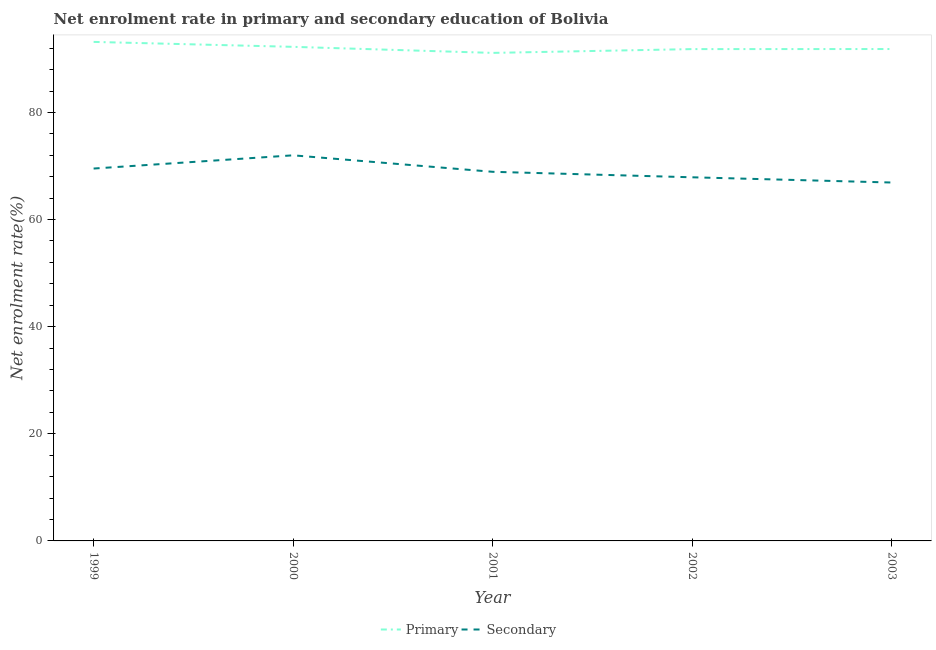How many different coloured lines are there?
Give a very brief answer. 2. Does the line corresponding to enrollment rate in primary education intersect with the line corresponding to enrollment rate in secondary education?
Keep it short and to the point. No. What is the enrollment rate in primary education in 2003?
Offer a very short reply. 91.84. Across all years, what is the maximum enrollment rate in primary education?
Ensure brevity in your answer.  93.17. Across all years, what is the minimum enrollment rate in secondary education?
Give a very brief answer. 66.92. In which year was the enrollment rate in primary education maximum?
Offer a terse response. 1999. In which year was the enrollment rate in primary education minimum?
Offer a terse response. 2001. What is the total enrollment rate in secondary education in the graph?
Give a very brief answer. 345.25. What is the difference between the enrollment rate in secondary education in 1999 and that in 2002?
Your answer should be very brief. 1.63. What is the difference between the enrollment rate in primary education in 2002 and the enrollment rate in secondary education in 2001?
Give a very brief answer. 22.91. What is the average enrollment rate in primary education per year?
Offer a terse response. 92.04. In the year 2003, what is the difference between the enrollment rate in primary education and enrollment rate in secondary education?
Make the answer very short. 24.92. What is the ratio of the enrollment rate in primary education in 2001 to that in 2002?
Make the answer very short. 0.99. Is the difference between the enrollment rate in secondary education in 1999 and 2001 greater than the difference between the enrollment rate in primary education in 1999 and 2001?
Your answer should be compact. No. What is the difference between the highest and the second highest enrollment rate in secondary education?
Ensure brevity in your answer.  2.47. What is the difference between the highest and the lowest enrollment rate in secondary education?
Make the answer very short. 5.08. In how many years, is the enrollment rate in secondary education greater than the average enrollment rate in secondary education taken over all years?
Your response must be concise. 2. Does the enrollment rate in primary education monotonically increase over the years?
Offer a very short reply. No. How many lines are there?
Your response must be concise. 2. How many years are there in the graph?
Make the answer very short. 5. What is the difference between two consecutive major ticks on the Y-axis?
Your answer should be very brief. 20. Are the values on the major ticks of Y-axis written in scientific E-notation?
Provide a succinct answer. No. Does the graph contain grids?
Provide a short and direct response. No. Where does the legend appear in the graph?
Make the answer very short. Bottom center. How many legend labels are there?
Give a very brief answer. 2. How are the legend labels stacked?
Make the answer very short. Horizontal. What is the title of the graph?
Ensure brevity in your answer.  Net enrolment rate in primary and secondary education of Bolivia. What is the label or title of the X-axis?
Keep it short and to the point. Year. What is the label or title of the Y-axis?
Keep it short and to the point. Net enrolment rate(%). What is the Net enrolment rate(%) in Primary in 1999?
Give a very brief answer. 93.17. What is the Net enrolment rate(%) of Secondary in 1999?
Your answer should be compact. 69.53. What is the Net enrolment rate(%) of Primary in 2000?
Your answer should be very brief. 92.25. What is the Net enrolment rate(%) of Secondary in 2000?
Your answer should be compact. 72. What is the Net enrolment rate(%) in Primary in 2001?
Provide a short and direct response. 91.12. What is the Net enrolment rate(%) in Secondary in 2001?
Your response must be concise. 68.92. What is the Net enrolment rate(%) of Primary in 2002?
Offer a terse response. 91.83. What is the Net enrolment rate(%) of Secondary in 2002?
Provide a succinct answer. 67.89. What is the Net enrolment rate(%) in Primary in 2003?
Offer a terse response. 91.84. What is the Net enrolment rate(%) of Secondary in 2003?
Ensure brevity in your answer.  66.92. Across all years, what is the maximum Net enrolment rate(%) in Primary?
Make the answer very short. 93.17. Across all years, what is the maximum Net enrolment rate(%) of Secondary?
Offer a terse response. 72. Across all years, what is the minimum Net enrolment rate(%) in Primary?
Offer a terse response. 91.12. Across all years, what is the minimum Net enrolment rate(%) of Secondary?
Offer a very short reply. 66.92. What is the total Net enrolment rate(%) in Primary in the graph?
Provide a succinct answer. 460.21. What is the total Net enrolment rate(%) in Secondary in the graph?
Ensure brevity in your answer.  345.25. What is the difference between the Net enrolment rate(%) in Primary in 1999 and that in 2000?
Your answer should be very brief. 0.92. What is the difference between the Net enrolment rate(%) in Secondary in 1999 and that in 2000?
Give a very brief answer. -2.47. What is the difference between the Net enrolment rate(%) of Primary in 1999 and that in 2001?
Keep it short and to the point. 2.05. What is the difference between the Net enrolment rate(%) of Secondary in 1999 and that in 2001?
Make the answer very short. 0.61. What is the difference between the Net enrolment rate(%) in Primary in 1999 and that in 2002?
Ensure brevity in your answer.  1.34. What is the difference between the Net enrolment rate(%) in Secondary in 1999 and that in 2002?
Give a very brief answer. 1.63. What is the difference between the Net enrolment rate(%) in Primary in 1999 and that in 2003?
Provide a short and direct response. 1.33. What is the difference between the Net enrolment rate(%) of Secondary in 1999 and that in 2003?
Your response must be concise. 2.61. What is the difference between the Net enrolment rate(%) of Primary in 2000 and that in 2001?
Your answer should be compact. 1.13. What is the difference between the Net enrolment rate(%) of Secondary in 2000 and that in 2001?
Give a very brief answer. 3.08. What is the difference between the Net enrolment rate(%) in Primary in 2000 and that in 2002?
Your answer should be compact. 0.42. What is the difference between the Net enrolment rate(%) of Secondary in 2000 and that in 2002?
Offer a very short reply. 4.1. What is the difference between the Net enrolment rate(%) in Primary in 2000 and that in 2003?
Your answer should be compact. 0.41. What is the difference between the Net enrolment rate(%) of Secondary in 2000 and that in 2003?
Provide a short and direct response. 5.08. What is the difference between the Net enrolment rate(%) of Primary in 2001 and that in 2002?
Give a very brief answer. -0.71. What is the difference between the Net enrolment rate(%) in Secondary in 2001 and that in 2002?
Keep it short and to the point. 1.03. What is the difference between the Net enrolment rate(%) of Primary in 2001 and that in 2003?
Your answer should be very brief. -0.72. What is the difference between the Net enrolment rate(%) of Secondary in 2001 and that in 2003?
Your response must be concise. 2. What is the difference between the Net enrolment rate(%) in Primary in 2002 and that in 2003?
Offer a very short reply. -0.01. What is the difference between the Net enrolment rate(%) in Secondary in 2002 and that in 2003?
Your response must be concise. 0.98. What is the difference between the Net enrolment rate(%) in Primary in 1999 and the Net enrolment rate(%) in Secondary in 2000?
Ensure brevity in your answer.  21.18. What is the difference between the Net enrolment rate(%) of Primary in 1999 and the Net enrolment rate(%) of Secondary in 2001?
Your response must be concise. 24.25. What is the difference between the Net enrolment rate(%) in Primary in 1999 and the Net enrolment rate(%) in Secondary in 2002?
Make the answer very short. 25.28. What is the difference between the Net enrolment rate(%) in Primary in 1999 and the Net enrolment rate(%) in Secondary in 2003?
Give a very brief answer. 26.25. What is the difference between the Net enrolment rate(%) in Primary in 2000 and the Net enrolment rate(%) in Secondary in 2001?
Make the answer very short. 23.33. What is the difference between the Net enrolment rate(%) in Primary in 2000 and the Net enrolment rate(%) in Secondary in 2002?
Keep it short and to the point. 24.36. What is the difference between the Net enrolment rate(%) of Primary in 2000 and the Net enrolment rate(%) of Secondary in 2003?
Keep it short and to the point. 25.33. What is the difference between the Net enrolment rate(%) in Primary in 2001 and the Net enrolment rate(%) in Secondary in 2002?
Make the answer very short. 23.23. What is the difference between the Net enrolment rate(%) in Primary in 2001 and the Net enrolment rate(%) in Secondary in 2003?
Your answer should be compact. 24.2. What is the difference between the Net enrolment rate(%) in Primary in 2002 and the Net enrolment rate(%) in Secondary in 2003?
Offer a terse response. 24.91. What is the average Net enrolment rate(%) of Primary per year?
Provide a succinct answer. 92.04. What is the average Net enrolment rate(%) in Secondary per year?
Ensure brevity in your answer.  69.05. In the year 1999, what is the difference between the Net enrolment rate(%) of Primary and Net enrolment rate(%) of Secondary?
Provide a succinct answer. 23.64. In the year 2000, what is the difference between the Net enrolment rate(%) of Primary and Net enrolment rate(%) of Secondary?
Offer a very short reply. 20.25. In the year 2001, what is the difference between the Net enrolment rate(%) of Primary and Net enrolment rate(%) of Secondary?
Ensure brevity in your answer.  22.2. In the year 2002, what is the difference between the Net enrolment rate(%) in Primary and Net enrolment rate(%) in Secondary?
Your answer should be compact. 23.93. In the year 2003, what is the difference between the Net enrolment rate(%) in Primary and Net enrolment rate(%) in Secondary?
Your answer should be very brief. 24.92. What is the ratio of the Net enrolment rate(%) of Primary in 1999 to that in 2000?
Make the answer very short. 1.01. What is the ratio of the Net enrolment rate(%) in Secondary in 1999 to that in 2000?
Ensure brevity in your answer.  0.97. What is the ratio of the Net enrolment rate(%) in Primary in 1999 to that in 2001?
Provide a succinct answer. 1.02. What is the ratio of the Net enrolment rate(%) of Secondary in 1999 to that in 2001?
Your response must be concise. 1.01. What is the ratio of the Net enrolment rate(%) of Primary in 1999 to that in 2002?
Give a very brief answer. 1.01. What is the ratio of the Net enrolment rate(%) of Secondary in 1999 to that in 2002?
Your response must be concise. 1.02. What is the ratio of the Net enrolment rate(%) of Primary in 1999 to that in 2003?
Your response must be concise. 1.01. What is the ratio of the Net enrolment rate(%) in Secondary in 1999 to that in 2003?
Offer a terse response. 1.04. What is the ratio of the Net enrolment rate(%) in Primary in 2000 to that in 2001?
Give a very brief answer. 1.01. What is the ratio of the Net enrolment rate(%) in Secondary in 2000 to that in 2001?
Offer a very short reply. 1.04. What is the ratio of the Net enrolment rate(%) in Secondary in 2000 to that in 2002?
Make the answer very short. 1.06. What is the ratio of the Net enrolment rate(%) in Primary in 2000 to that in 2003?
Provide a succinct answer. 1. What is the ratio of the Net enrolment rate(%) of Secondary in 2000 to that in 2003?
Provide a short and direct response. 1.08. What is the ratio of the Net enrolment rate(%) of Primary in 2001 to that in 2002?
Make the answer very short. 0.99. What is the ratio of the Net enrolment rate(%) of Secondary in 2001 to that in 2002?
Offer a very short reply. 1.02. What is the ratio of the Net enrolment rate(%) of Secondary in 2001 to that in 2003?
Offer a terse response. 1.03. What is the ratio of the Net enrolment rate(%) in Secondary in 2002 to that in 2003?
Provide a short and direct response. 1.01. What is the difference between the highest and the second highest Net enrolment rate(%) of Primary?
Your answer should be very brief. 0.92. What is the difference between the highest and the second highest Net enrolment rate(%) in Secondary?
Your answer should be very brief. 2.47. What is the difference between the highest and the lowest Net enrolment rate(%) of Primary?
Provide a short and direct response. 2.05. What is the difference between the highest and the lowest Net enrolment rate(%) in Secondary?
Keep it short and to the point. 5.08. 